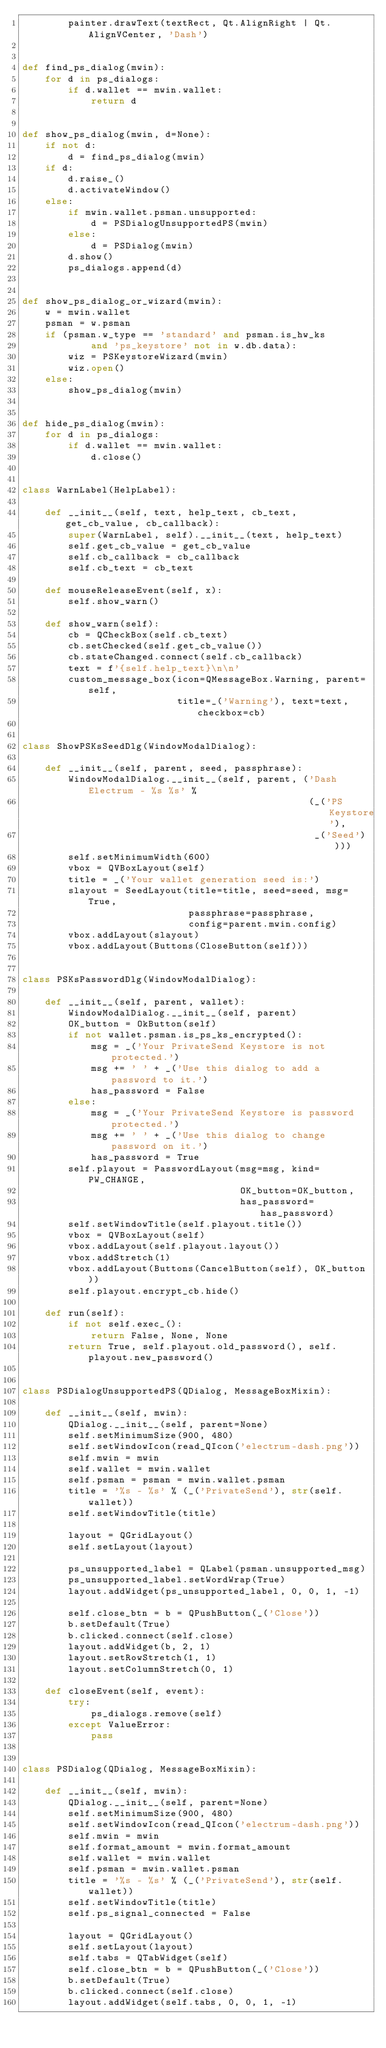<code> <loc_0><loc_0><loc_500><loc_500><_Python_>        painter.drawText(textRect, Qt.AlignRight | Qt.AlignVCenter, 'Dash')


def find_ps_dialog(mwin):
    for d in ps_dialogs:
        if d.wallet == mwin.wallet:
            return d


def show_ps_dialog(mwin, d=None):
    if not d:
        d = find_ps_dialog(mwin)
    if d:
        d.raise_()
        d.activateWindow()
    else:
        if mwin.wallet.psman.unsupported:
            d = PSDialogUnsupportedPS(mwin)
        else:
            d = PSDialog(mwin)
        d.show()
        ps_dialogs.append(d)


def show_ps_dialog_or_wizard(mwin):
    w = mwin.wallet
    psman = w.psman
    if (psman.w_type == 'standard' and psman.is_hw_ks
            and 'ps_keystore' not in w.db.data):
        wiz = PSKeystoreWizard(mwin)
        wiz.open()
    else:
        show_ps_dialog(mwin)


def hide_ps_dialog(mwin):
    for d in ps_dialogs:
        if d.wallet == mwin.wallet:
            d.close()


class WarnLabel(HelpLabel):

    def __init__(self, text, help_text, cb_text, get_cb_value, cb_callback):
        super(WarnLabel, self).__init__(text, help_text)
        self.get_cb_value = get_cb_value
        self.cb_callback = cb_callback
        self.cb_text = cb_text

    def mouseReleaseEvent(self, x):
        self.show_warn()

    def show_warn(self):
        cb = QCheckBox(self.cb_text)
        cb.setChecked(self.get_cb_value())
        cb.stateChanged.connect(self.cb_callback)
        text = f'{self.help_text}\n\n'
        custom_message_box(icon=QMessageBox.Warning, parent=self,
                           title=_('Warning'), text=text, checkbox=cb)


class ShowPSKsSeedDlg(WindowModalDialog):

    def __init__(self, parent, seed, passphrase):
        WindowModalDialog.__init__(self, parent, ('Dash Electrum - %s %s' %
                                                  (_('PS Keystore'),
                                                   _('Seed'))))
        self.setMinimumWidth(600)
        vbox = QVBoxLayout(self)
        title = _('Your wallet generation seed is:')
        slayout = SeedLayout(title=title, seed=seed, msg=True,
                             passphrase=passphrase,
                             config=parent.mwin.config)
        vbox.addLayout(slayout)
        vbox.addLayout(Buttons(CloseButton(self)))


class PSKsPasswordDlg(WindowModalDialog):

    def __init__(self, parent, wallet):
        WindowModalDialog.__init__(self, parent)
        OK_button = OkButton(self)
        if not wallet.psman.is_ps_ks_encrypted():
            msg = _('Your PrivateSend Keystore is not protected.')
            msg += ' ' + _('Use this dialog to add a password to it.')
            has_password = False
        else:
            msg = _('Your PrivateSend Keystore is password protected.')
            msg += ' ' + _('Use this dialog to change password on it.')
            has_password = True
        self.playout = PasswordLayout(msg=msg, kind=PW_CHANGE,
                                      OK_button=OK_button,
                                      has_password=has_password)
        self.setWindowTitle(self.playout.title())
        vbox = QVBoxLayout(self)
        vbox.addLayout(self.playout.layout())
        vbox.addStretch(1)
        vbox.addLayout(Buttons(CancelButton(self), OK_button))
        self.playout.encrypt_cb.hide()

    def run(self):
        if not self.exec_():
            return False, None, None
        return True, self.playout.old_password(), self.playout.new_password()


class PSDialogUnsupportedPS(QDialog, MessageBoxMixin):

    def __init__(self, mwin):
        QDialog.__init__(self, parent=None)
        self.setMinimumSize(900, 480)
        self.setWindowIcon(read_QIcon('electrum-dash.png'))
        self.mwin = mwin
        self.wallet = mwin.wallet
        self.psman = psman = mwin.wallet.psman
        title = '%s - %s' % (_('PrivateSend'), str(self.wallet))
        self.setWindowTitle(title)

        layout = QGridLayout()
        self.setLayout(layout)

        ps_unsupported_label = QLabel(psman.unsupported_msg)
        ps_unsupported_label.setWordWrap(True)
        layout.addWidget(ps_unsupported_label, 0, 0, 1, -1)

        self.close_btn = b = QPushButton(_('Close'))
        b.setDefault(True)
        b.clicked.connect(self.close)
        layout.addWidget(b, 2, 1)
        layout.setRowStretch(1, 1)
        layout.setColumnStretch(0, 1)

    def closeEvent(self, event):
        try:
            ps_dialogs.remove(self)
        except ValueError:
            pass


class PSDialog(QDialog, MessageBoxMixin):

    def __init__(self, mwin):
        QDialog.__init__(self, parent=None)
        self.setMinimumSize(900, 480)
        self.setWindowIcon(read_QIcon('electrum-dash.png'))
        self.mwin = mwin
        self.format_amount = mwin.format_amount
        self.wallet = mwin.wallet
        self.psman = mwin.wallet.psman
        title = '%s - %s' % (_('PrivateSend'), str(self.wallet))
        self.setWindowTitle(title)
        self.ps_signal_connected = False

        layout = QGridLayout()
        self.setLayout(layout)
        self.tabs = QTabWidget(self)
        self.close_btn = b = QPushButton(_('Close'))
        b.setDefault(True)
        b.clicked.connect(self.close)
        layout.addWidget(self.tabs, 0, 0, 1, -1)</code> 